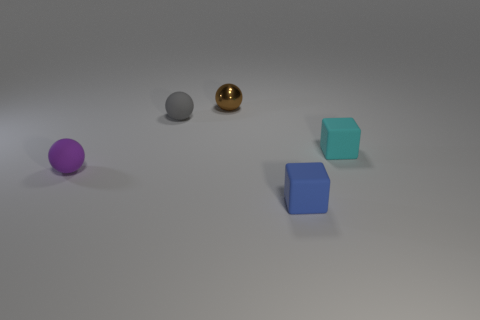The small rubber object that is both in front of the cyan rubber thing and behind the blue rubber block has what shape? sphere 